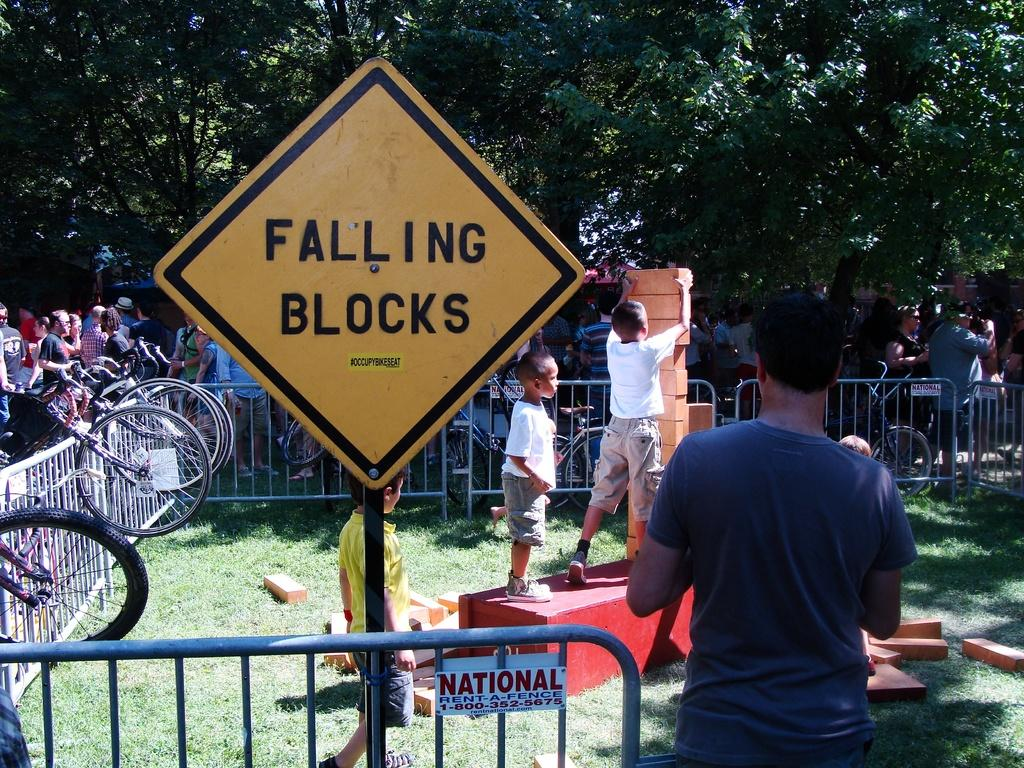What can be seen in the foreground of the picture? In the foreground of the picture, there are people, bricks, a railing, a bicycle, grass, a board, and other objects. Can you describe the objects in the foreground in more detail? The people are standing or walking, the bricks are part of a structure, the railing is likely for safety or support, the bicycle is a mode of transportation, the grass is a natural element, the board could be a sign or notice, and the other objects are unspecified but visible. What is visible in the background of the picture? In the background of the picture, there are cars and trees. What type of chess piece is depicted on the board in the foreground of the image? There is no chess piece or board present in the image. What is the purpose of the people smashing the bricks in the foreground of the image? There is no indication in the image that the people are smashing bricks or that they have a specific purpose. 